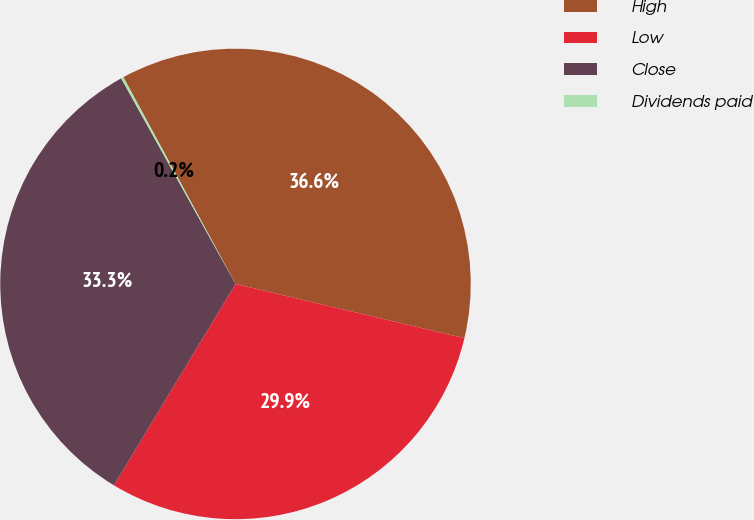Convert chart to OTSL. <chart><loc_0><loc_0><loc_500><loc_500><pie_chart><fcel>High<fcel>Low<fcel>Close<fcel>Dividends paid<nl><fcel>36.62%<fcel>29.94%<fcel>33.28%<fcel>0.17%<nl></chart> 